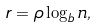<formula> <loc_0><loc_0><loc_500><loc_500>r = \rho \log _ { b } n ,</formula> 